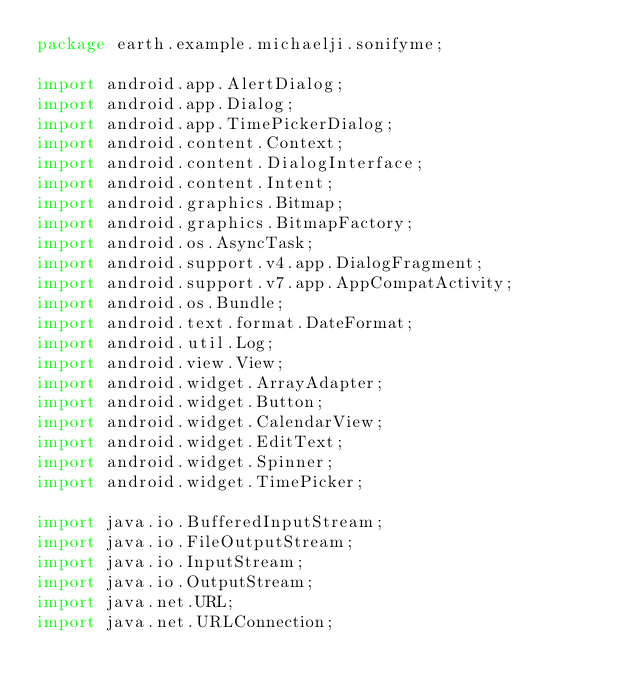Convert code to text. <code><loc_0><loc_0><loc_500><loc_500><_Java_>package earth.example.michaelji.sonifyme;

import android.app.AlertDialog;
import android.app.Dialog;
import android.app.TimePickerDialog;
import android.content.Context;
import android.content.DialogInterface;
import android.content.Intent;
import android.graphics.Bitmap;
import android.graphics.BitmapFactory;
import android.os.AsyncTask;
import android.support.v4.app.DialogFragment;
import android.support.v7.app.AppCompatActivity;
import android.os.Bundle;
import android.text.format.DateFormat;
import android.util.Log;
import android.view.View;
import android.widget.ArrayAdapter;
import android.widget.Button;
import android.widget.CalendarView;
import android.widget.EditText;
import android.widget.Spinner;
import android.widget.TimePicker;

import java.io.BufferedInputStream;
import java.io.FileOutputStream;
import java.io.InputStream;
import java.io.OutputStream;
import java.net.URL;
import java.net.URLConnection;</code> 